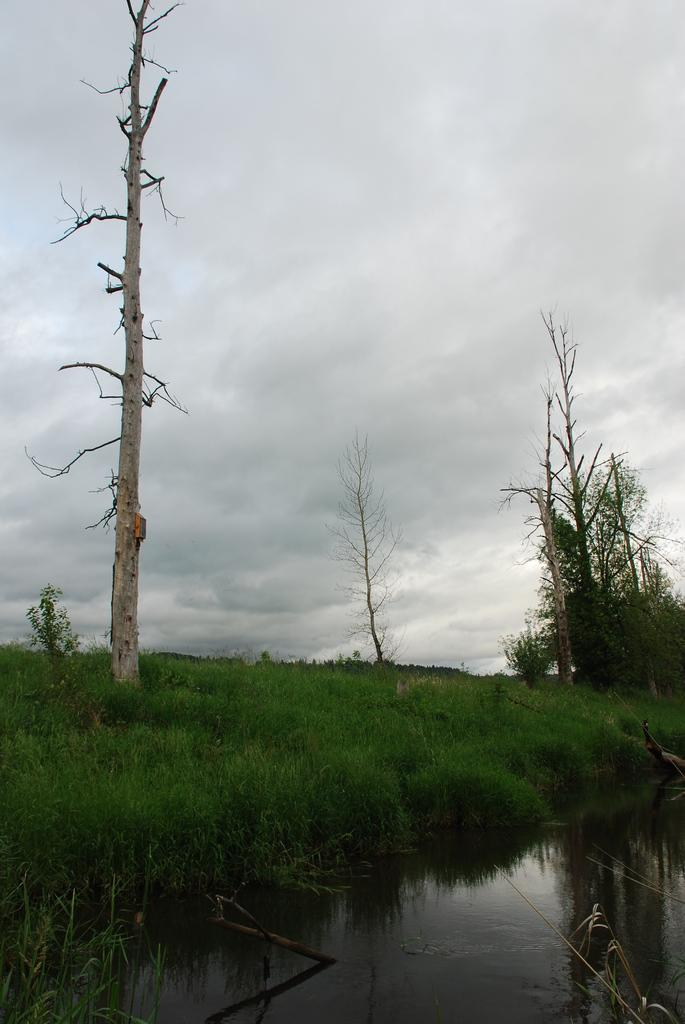What is at the bottom of the image? There is water at the bottom of the image. What can be seen in the distance in the image? There are trees and plants in the background of the image. What type of vegetation is present on the ground in the background? There is grass on the ground in the background of the image. What is visible in the sky in the image? There are clouds in the sky. What home discovery was made in the image? There is no mention of a home or any discovery in the image; it primarily features natural elements like water, trees, plants, grass, and clouds. 